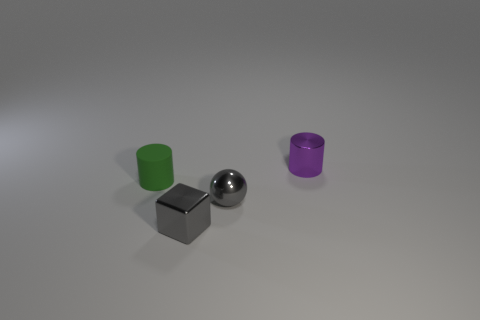Add 4 small spheres. How many objects exist? 8 Subtract all balls. How many objects are left? 3 Add 1 gray shiny cubes. How many gray shiny cubes are left? 2 Add 4 tiny green objects. How many tiny green objects exist? 5 Subtract 1 purple cylinders. How many objects are left? 3 Subtract all small gray shiny cubes. Subtract all rubber objects. How many objects are left? 2 